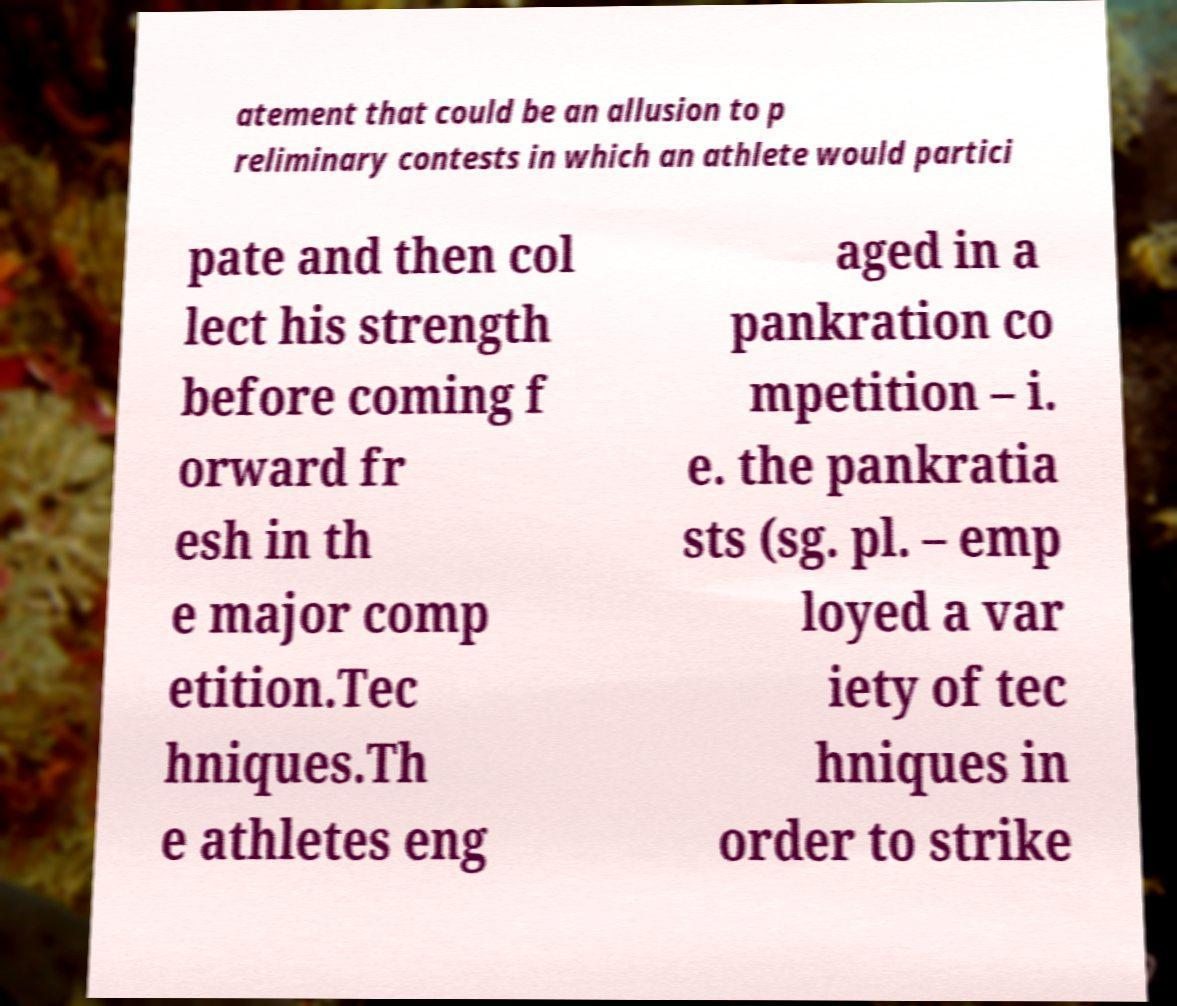Please identify and transcribe the text found in this image. atement that could be an allusion to p reliminary contests in which an athlete would partici pate and then col lect his strength before coming f orward fr esh in th e major comp etition.Tec hniques.Th e athletes eng aged in a pankration co mpetition – i. e. the pankratia sts (sg. pl. – emp loyed a var iety of tec hniques in order to strike 